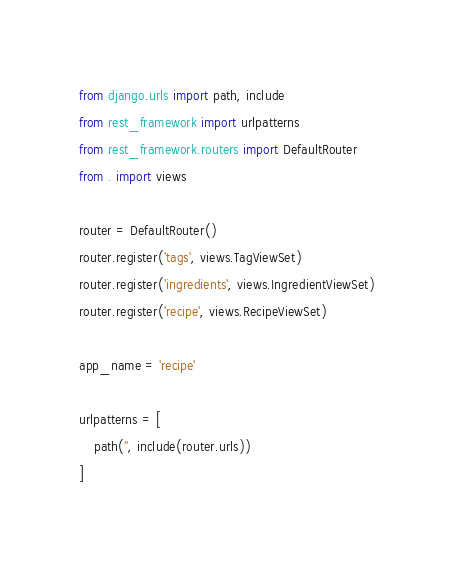<code> <loc_0><loc_0><loc_500><loc_500><_Python_>from django.urls import path, include
from rest_framework import urlpatterns
from rest_framework.routers import DefaultRouter
from . import views

router = DefaultRouter()
router.register('tags', views.TagViewSet)
router.register('ingredients', views.IngredientViewSet)
router.register('recipe', views.RecipeViewSet)

app_name = 'recipe'

urlpatterns = [
    path('', include(router.urls))
]

</code> 